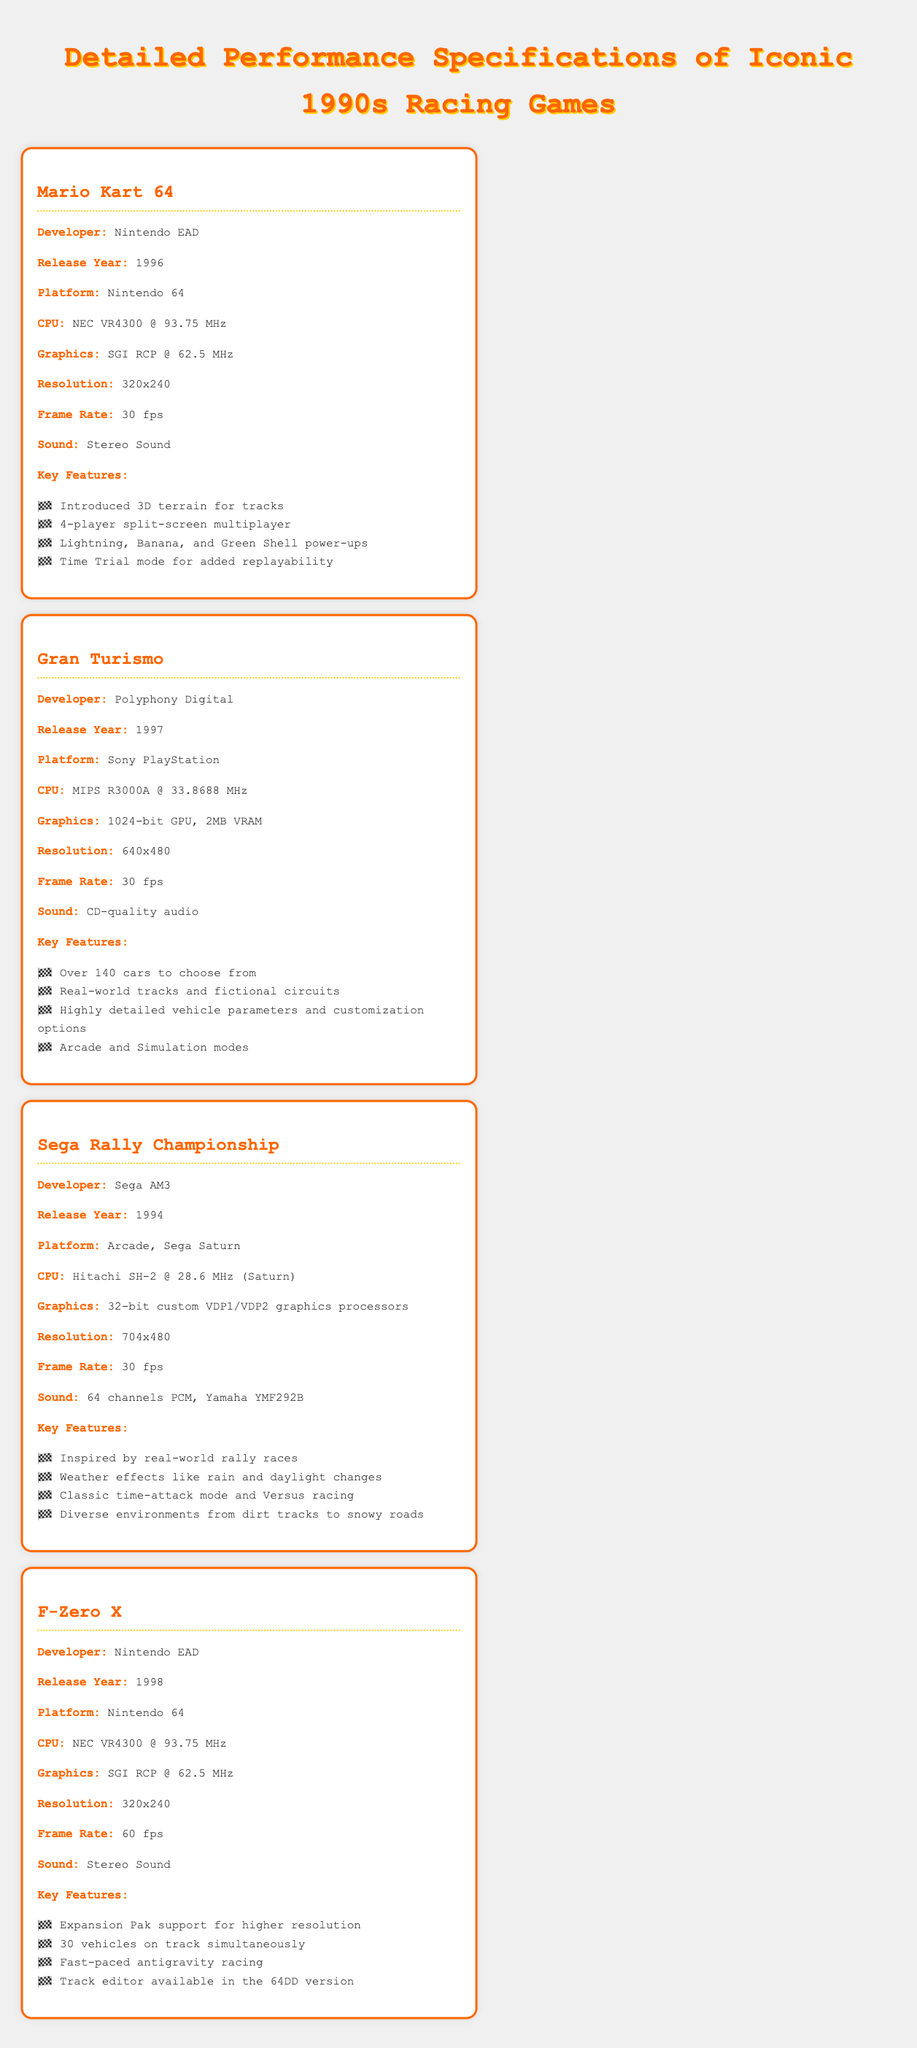What is the release year of Mario Kart 64? The release year of Mario Kart 64 is explicitly mentioned in the document.
Answer: 1996 What platform is Gran Turismo available on? The platform for Gran Turismo is indicated in the document.
Answer: Sony PlayStation How many cars are available in Gran Turismo? The specification mentions the number of cars in Gran Turismo.
Answer: Over 140 What is the frame rate of F-Zero X? The document specifies the frame rate for F-Zero X directly.
Answer: 60 fps Which developer created Sega Rally Championship? The developer of Sega Rally Championship is stated in the document.
Answer: Sega AM3 What key feature is unique to F-Zero X compared to the other games listed? Comparing the key features shows that F-Zero X has a track editor available in the 64DD version, which is not mentioned for other games.
Answer: Track editor What is the CPU used in Mario Kart 64? The document provides details about the CPU used in Mario Kart 64.
Answer: NEC VR4300 @ 93.75 MHz Which game introduced 3D terrain for tracks? The key features section for Mario Kart 64 specifies that it introduced 3D terrain for tracks.
Answer: Mario Kart 64 What type of sound does Sega Rally Championship have? The document explicitly describes the sound type for Sega Rally Championship.
Answer: 64 channels PCM, Yamaha YMF292B 